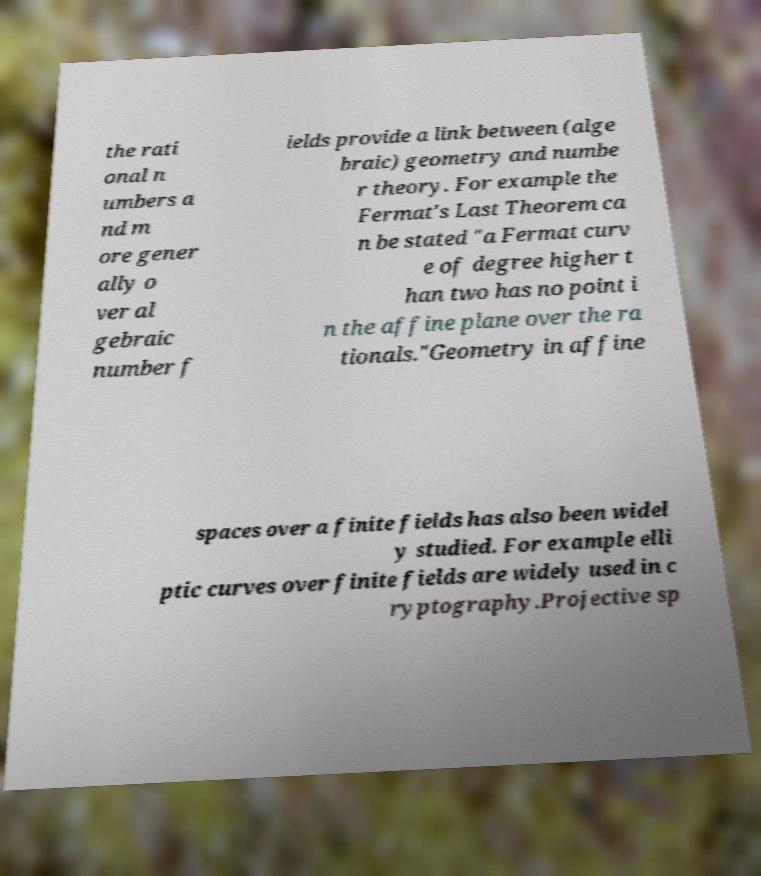Could you assist in decoding the text presented in this image and type it out clearly? the rati onal n umbers a nd m ore gener ally o ver al gebraic number f ields provide a link between (alge braic) geometry and numbe r theory. For example the Fermat's Last Theorem ca n be stated "a Fermat curv e of degree higher t han two has no point i n the affine plane over the ra tionals."Geometry in affine spaces over a finite fields has also been widel y studied. For example elli ptic curves over finite fields are widely used in c ryptography.Projective sp 